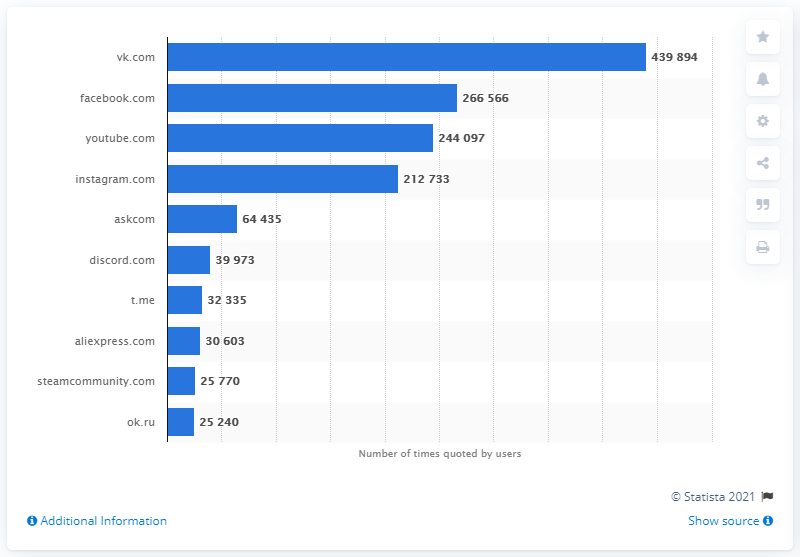Specify some key components in this picture. According to a study conducted in 2018, ok.ru was the 10th most popular online resource among teenagers in Russia. 